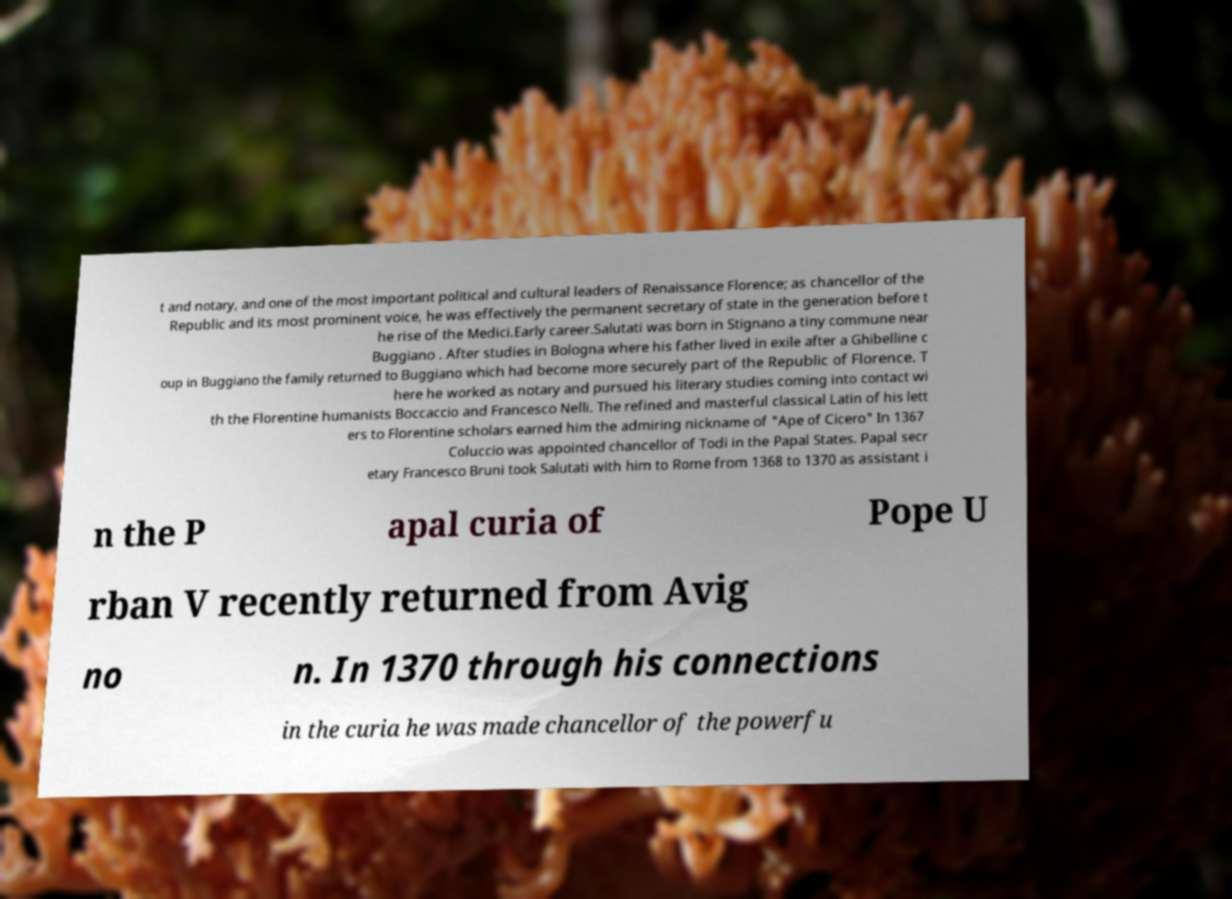Please identify and transcribe the text found in this image. t and notary, and one of the most important political and cultural leaders of Renaissance Florence; as chancellor of the Republic and its most prominent voice, he was effectively the permanent secretary of state in the generation before t he rise of the Medici.Early career.Salutati was born in Stignano a tiny commune near Buggiano . After studies in Bologna where his father lived in exile after a Ghibelline c oup in Buggiano the family returned to Buggiano which had become more securely part of the Republic of Florence. T here he worked as notary and pursued his literary studies coming into contact wi th the Florentine humanists Boccaccio and Francesco Nelli. The refined and masterful classical Latin of his lett ers to Florentine scholars earned him the admiring nickname of "Ape of Cicero" In 1367 Coluccio was appointed chancellor of Todi in the Papal States. Papal secr etary Francesco Bruni took Salutati with him to Rome from 1368 to 1370 as assistant i n the P apal curia of Pope U rban V recently returned from Avig no n. In 1370 through his connections in the curia he was made chancellor of the powerfu 